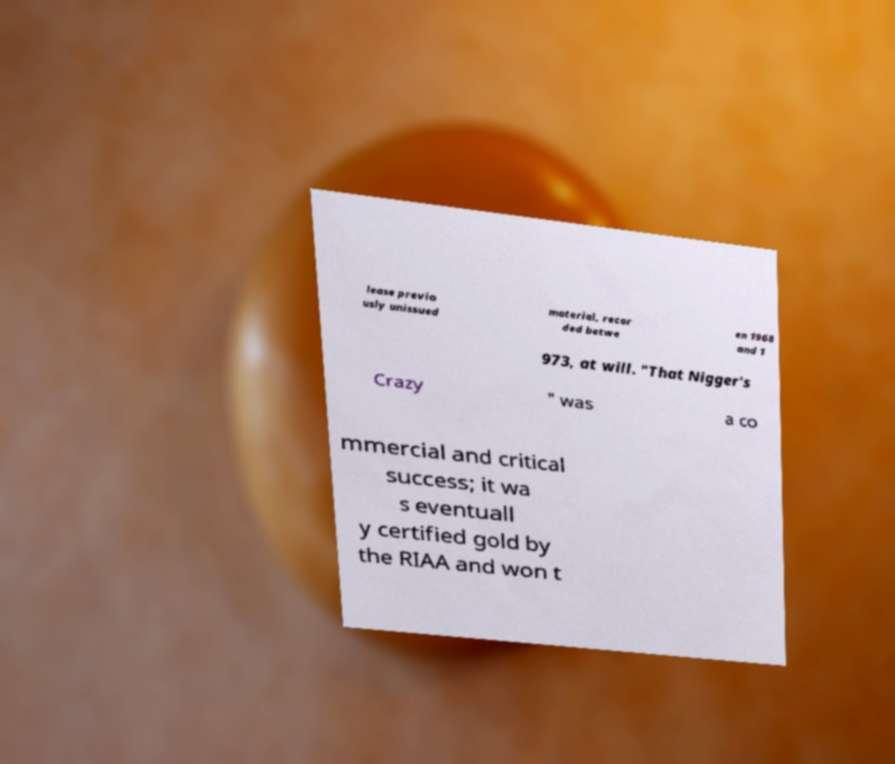For documentation purposes, I need the text within this image transcribed. Could you provide that? lease previo usly unissued material, recor ded betwe en 1968 and 1 973, at will. "That Nigger's Crazy " was a co mmercial and critical success; it wa s eventuall y certified gold by the RIAA and won t 